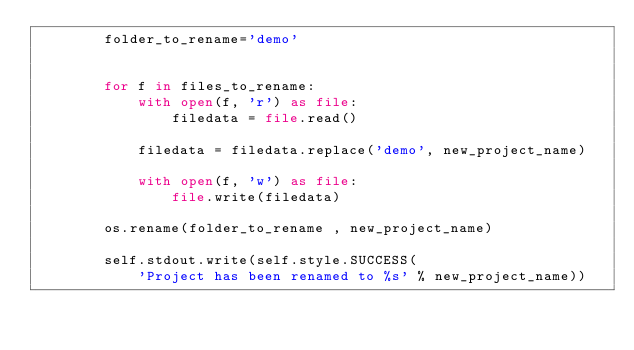Convert code to text. <code><loc_0><loc_0><loc_500><loc_500><_Python_>        folder_to_rename='demo'

        
        for f in files_to_rename:
            with open(f, 'r') as file:
                filedata = file.read()

            filedata = filedata.replace('demo', new_project_name)

            with open(f, 'w') as file:
                file.write(filedata)

        os.rename(folder_to_rename , new_project_name)
 
        self.stdout.write(self.style.SUCCESS(
            'Project has been renamed to %s' % new_project_name))</code> 